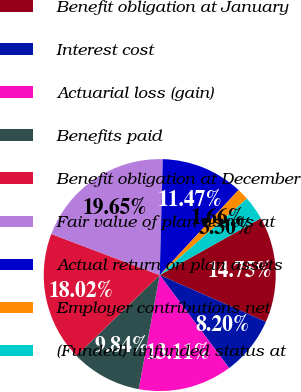Convert chart. <chart><loc_0><loc_0><loc_500><loc_500><pie_chart><fcel>Benefit obligation at January<fcel>Interest cost<fcel>Actuarial loss (gain)<fcel>Benefits paid<fcel>Benefit obligation at December<fcel>Fair value of plan assets at<fcel>Actual return on plan assets<fcel>Employer contributions net<fcel>(Funded) unfunded status at<nl><fcel>14.75%<fcel>8.2%<fcel>13.11%<fcel>9.84%<fcel>18.02%<fcel>19.65%<fcel>11.47%<fcel>1.66%<fcel>3.3%<nl></chart> 